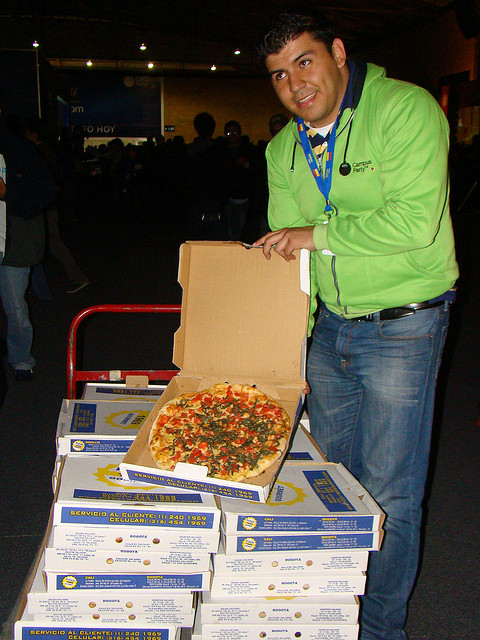<image>Is there plenty of donuts for people to eat? I don't know if there are plenty of donuts for people to eat. It is also possible that there are no donuts. Is there plenty of donuts for people to eat? There are no plenty of donuts for people to eat. 